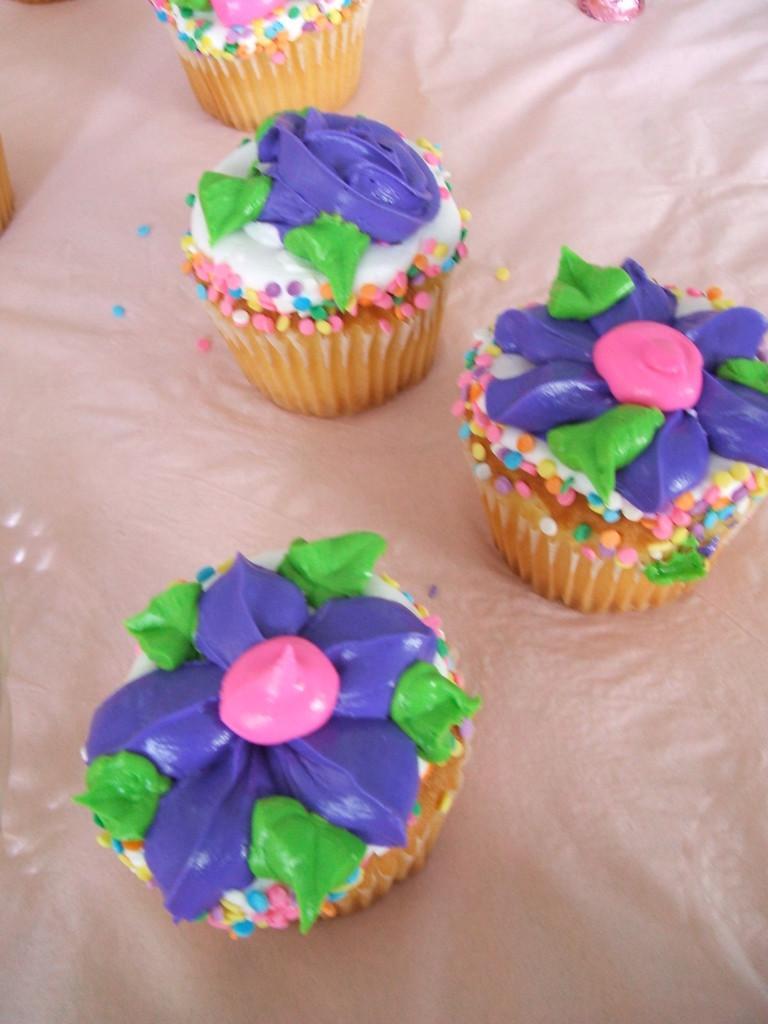Could you give a brief overview of what you see in this image? In the image on the white surface there are four cupcakes. On the cupcakes there are violet, green and pink color cream on it. 